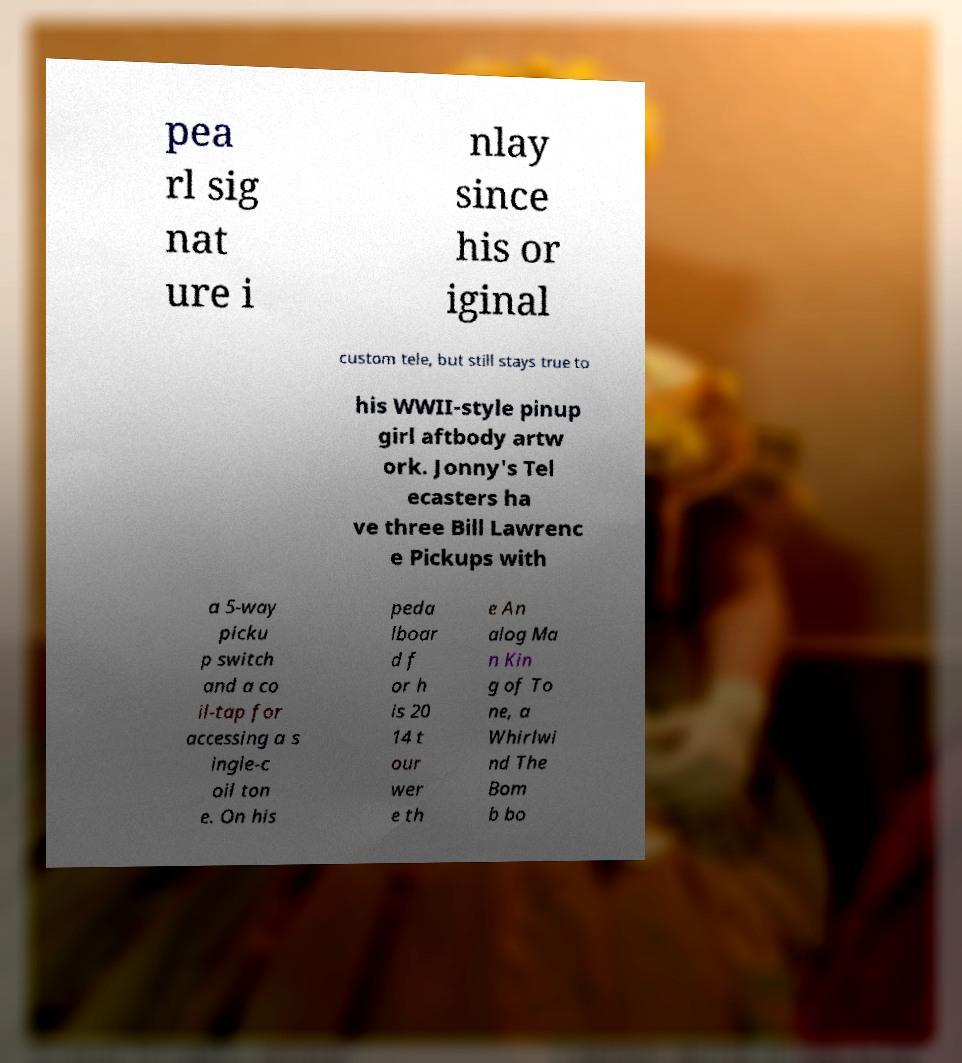I need the written content from this picture converted into text. Can you do that? pea rl sig nat ure i nlay since his or iginal custom tele, but still stays true to his WWII-style pinup girl aftbody artw ork. Jonny's Tel ecasters ha ve three Bill Lawrenc e Pickups with a 5-way picku p switch and a co il-tap for accessing a s ingle-c oil ton e. On his peda lboar d f or h is 20 14 t our wer e th e An alog Ma n Kin g of To ne, a Whirlwi nd The Bom b bo 